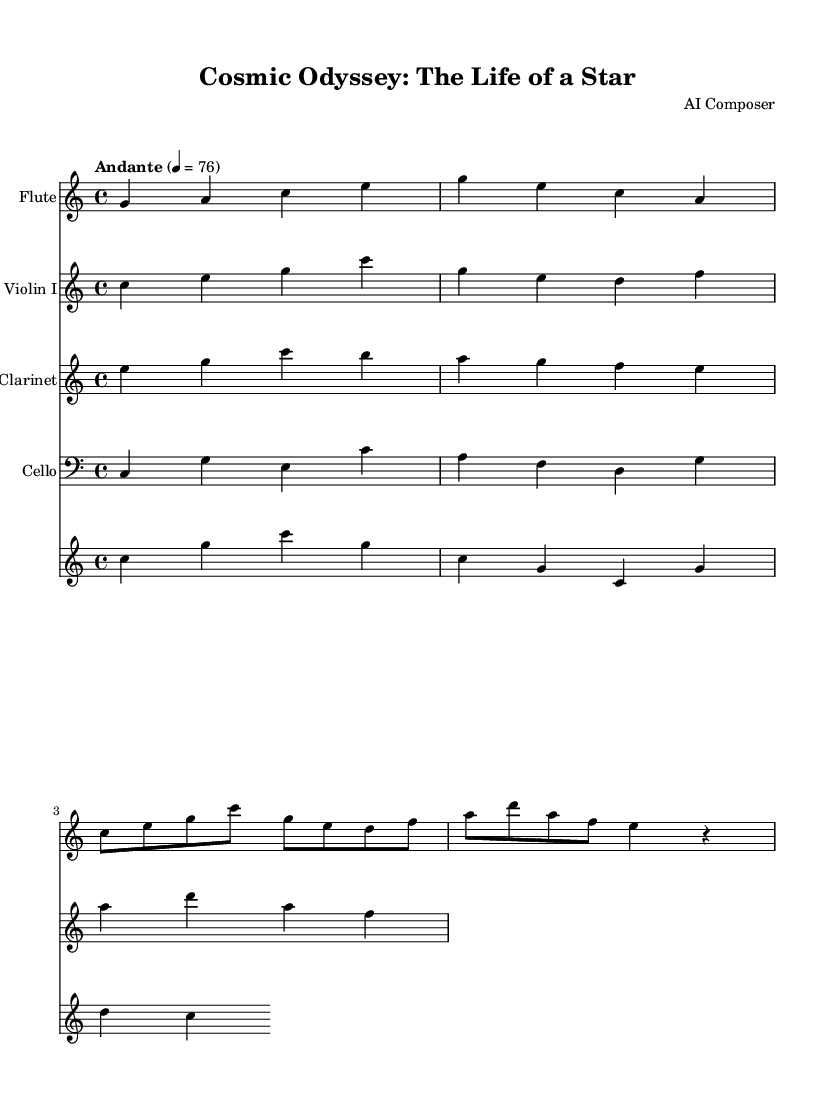What is the key signature of this music? The key signature is indicated at the beginning of the score, which shows C major, as there are no sharps or flats present.
Answer: C major What is the time signature of this piece? The time signature is shown following the key signature, represented as 4/4, indicating four beats per measure.
Answer: 4/4 What tempo marking is given in the score? The tempo marking is explicitly noted in the score as "Andante," with a metronome setting of quarter note equals 76.
Answer: Andante How many instruments are featured in this piece? The score details include five distinct staff sections, which represent the instruments: flute, violin, clarinet, cello, and the orchestra part.
Answer: Five Which instrument plays the highest pitch in the score? Analyzing the individual staves, the flute part has notes reaching higher pitches (such as c'' and e) compared to others like cello and clarinet, placing it as the highest.
Answer: Flute What musical form can be inferred from the layout of the score? The presence of multiple independent staves suggests a symphonic or orchestral form, where various instruments harmonically support the central melodic ideas.
Answer: Orchestral form 